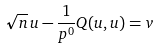<formula> <loc_0><loc_0><loc_500><loc_500>\sqrt { n } \, u - \frac { 1 } { p ^ { 0 } } Q ( u , u ) = v</formula> 